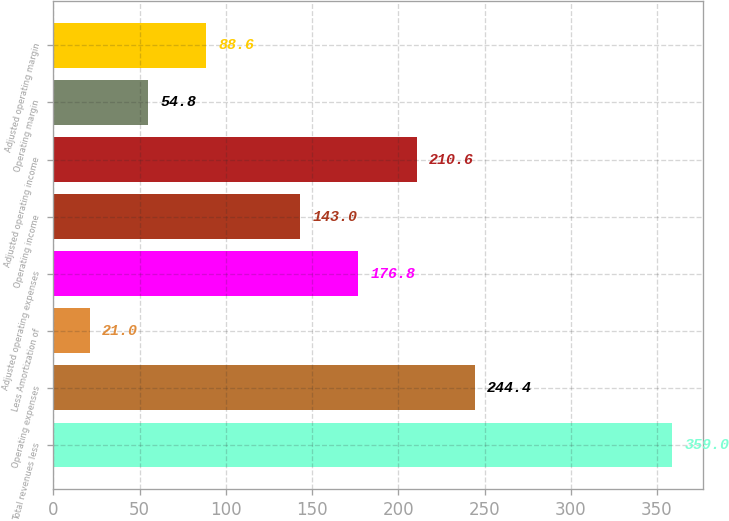<chart> <loc_0><loc_0><loc_500><loc_500><bar_chart><fcel>Total revenues less<fcel>Operating expenses<fcel>Less Amortization of<fcel>Adjusted operating expenses<fcel>Operating income<fcel>Adjusted operating income<fcel>Operating margin<fcel>Adjusted operating margin<nl><fcel>359<fcel>244.4<fcel>21<fcel>176.8<fcel>143<fcel>210.6<fcel>54.8<fcel>88.6<nl></chart> 